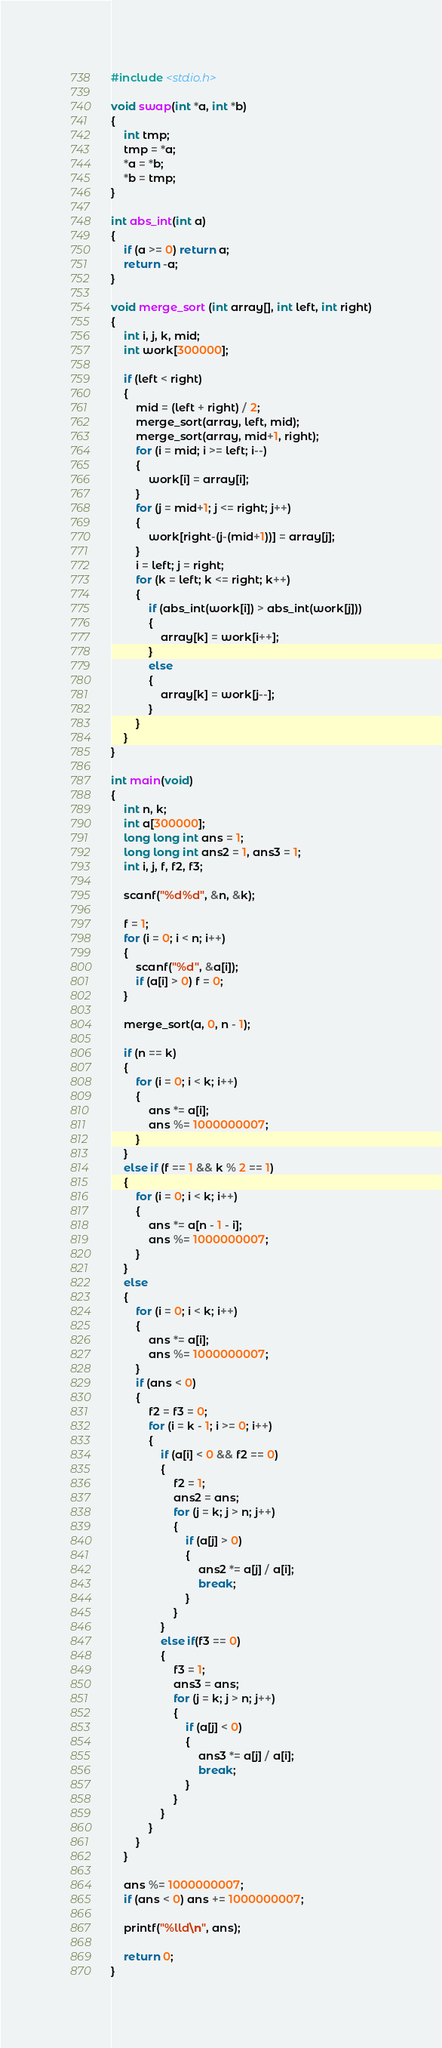Convert code to text. <code><loc_0><loc_0><loc_500><loc_500><_C_>#include <stdio.h>

void swap(int *a, int *b)
{
	int tmp;
	tmp = *a;
	*a = *b;
	*b = tmp;
}

int abs_int(int a)
{
	if (a >= 0) return a;
	return -a;
}

void merge_sort (int array[], int left, int right)
{
	int i, j, k, mid;
	int work[300000];

	if (left < right)
	{
		mid = (left + right) / 2;
		merge_sort(array, left, mid);
		merge_sort(array, mid+1, right);
		for (i = mid; i >= left; i--)
		{
			work[i] = array[i];
		}
		for (j = mid+1; j <= right; j++)
		{
			work[right-(j-(mid+1))] = array[j];
		}
		i = left; j = right;
		for (k = left; k <= right; k++)
		{
			if (abs_int(work[i]) > abs_int(work[j]))
			{
				array[k] = work[i++];
			}
			else
			{
				array[k] = work[j--];
			}
		}
	}
}

int main(void)
{
	int n, k;
	int a[300000];
	long long int ans = 1;
	long long int ans2 = 1, ans3 = 1;
	int i, j, f, f2, f3;

	scanf("%d%d", &n, &k);

	f = 1;
	for (i = 0; i < n; i++)
	{
		scanf("%d", &a[i]);
		if (a[i] > 0) f = 0;
	}

	merge_sort(a, 0, n - 1);

	if (n == k)
	{
		for (i = 0; i < k; i++)
		{
			ans *= a[i];
			ans %= 1000000007;
		}
	}
	else if (f == 1 && k % 2 == 1)
	{
		for (i = 0; i < k; i++)
		{
			ans *= a[n - 1 - i];
			ans %= 1000000007;
		}
	}
	else
	{
		for (i = 0; i < k; i++)
		{
			ans *= a[i];
			ans %= 1000000007;
		}
		if (ans < 0)
		{
			f2 = f3 = 0;
			for (i = k - 1; i >= 0; i++)
			{
				if (a[i] < 0 && f2 == 0)
				{
					f2 = 1;
					ans2 = ans;
					for (j = k; j > n; j++)
					{
						if (a[j] > 0)
						{
							ans2 *= a[j] / a[i];
							break;
						}
					}
				}
				else if(f3 == 0)
				{
					f3 = 1;
					ans3 = ans;
					for (j = k; j > n; j++)
					{
						if (a[j] < 0)
						{
							ans3 *= a[j] / a[i];
							break;
						}
					}
				}
			}
		}
	}

	ans %= 1000000007;
	if (ans < 0) ans += 1000000007;

	printf("%lld\n", ans);

	return 0;
}
</code> 